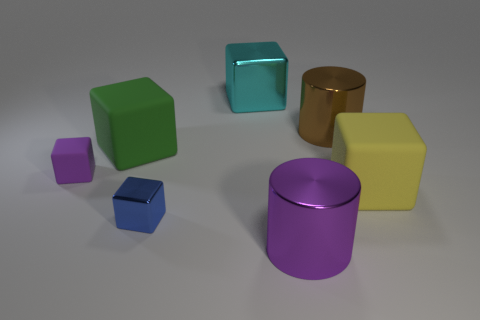Which object in the image looks most reflective? The cylindrical object on the right side of the image appears to be the most reflective, as it has a glossy surface that reflects light, giving it a metallic sheen. 